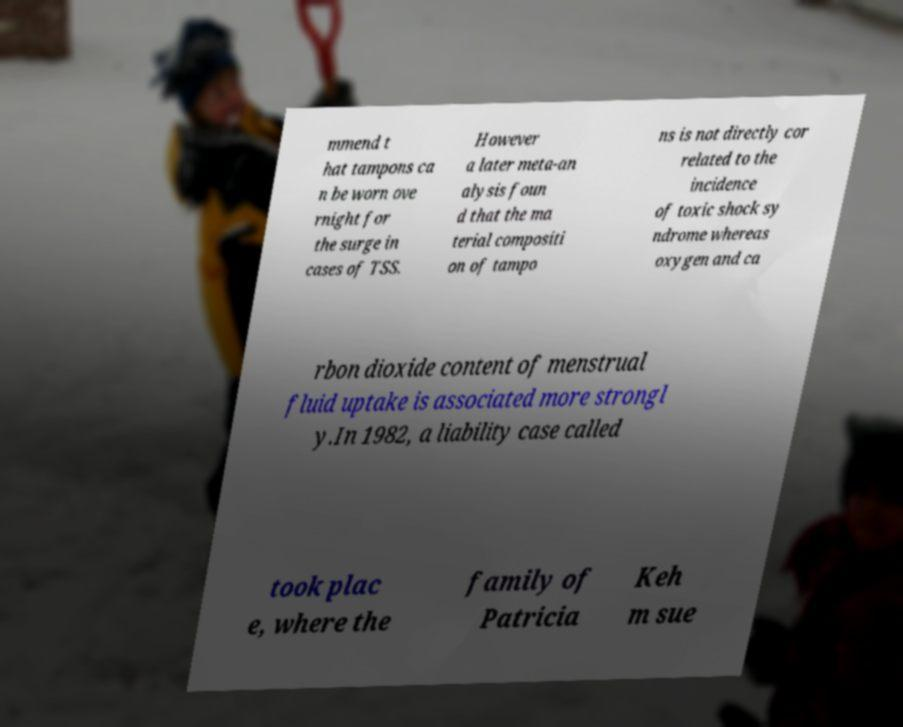Could you assist in decoding the text presented in this image and type it out clearly? mmend t hat tampons ca n be worn ove rnight for the surge in cases of TSS. However a later meta-an alysis foun d that the ma terial compositi on of tampo ns is not directly cor related to the incidence of toxic shock sy ndrome whereas oxygen and ca rbon dioxide content of menstrual fluid uptake is associated more strongl y.In 1982, a liability case called took plac e, where the family of Patricia Keh m sue 